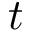Convert formula to latex. <formula><loc_0><loc_0><loc_500><loc_500>t</formula> 